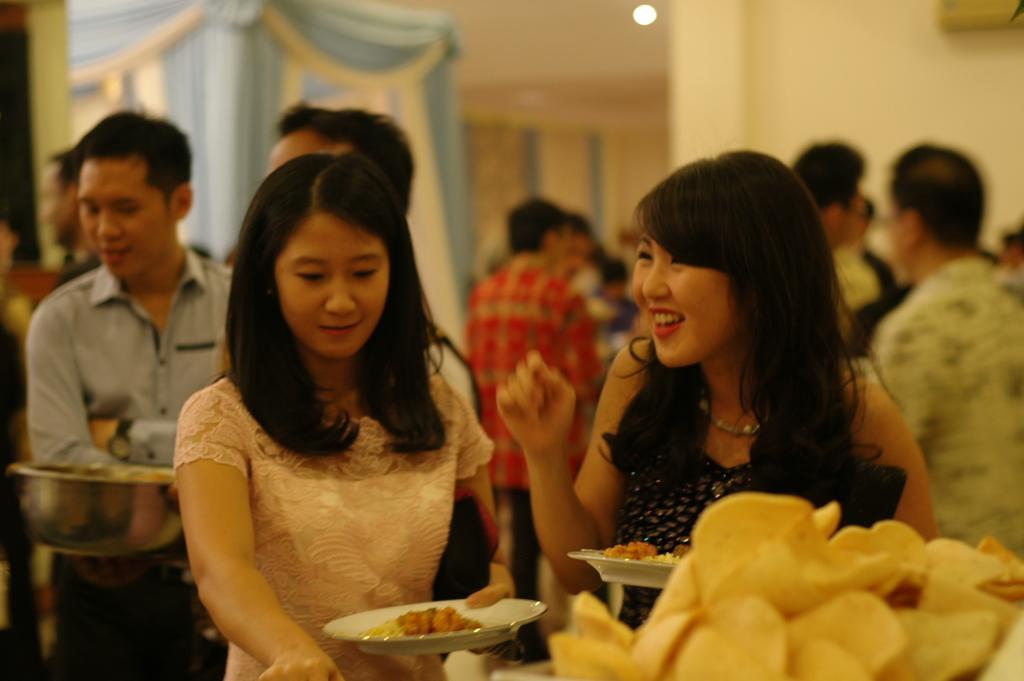Please provide a concise description of this image. In front of the image there is a food item. There are two people holding the plates. Behind them there are a few other people standing. In the background of the image there is some object on the wall. There are curtains. On top of the image there is a light. 